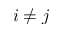Convert formula to latex. <formula><loc_0><loc_0><loc_500><loc_500>i \neq j</formula> 